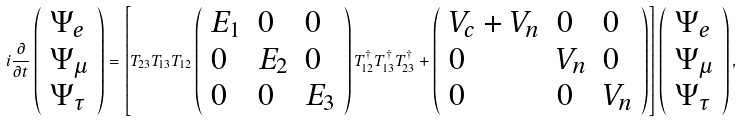<formula> <loc_0><loc_0><loc_500><loc_500>i \frac { \partial } { \partial t } \left ( \begin{array} { l } { { \Psi _ { e } } } \\ { { \Psi _ { \mu } } } \\ { { \Psi _ { \tau } } } \end{array} \right ) = \left [ T _ { 2 3 } T _ { 1 3 } T _ { 1 2 } \left ( \begin{array} { l l l } { { E _ { 1 } } } & { 0 } & { 0 } \\ { 0 } & { { E _ { 2 } } } & { 0 } \\ { 0 } & { 0 } & { { E _ { 3 } } } \end{array} \right ) T _ { 1 2 } ^ { \dagger } T _ { 1 3 } ^ { \dagger } T _ { 2 3 } ^ { \dagger } + \left ( \begin{array} { l l l } { { V _ { c } + V _ { n } } } & { 0 } & { 0 } \\ { 0 } & { { V _ { n } } } & { 0 } \\ { 0 } & { 0 } & { { V _ { n } } } \end{array} \right ) \right ] \left ( \begin{array} { l } { { \Psi _ { e } } } \\ { { \Psi _ { \mu } } } \\ { { \Psi _ { \tau } } } \end{array} \right ) ,</formula> 